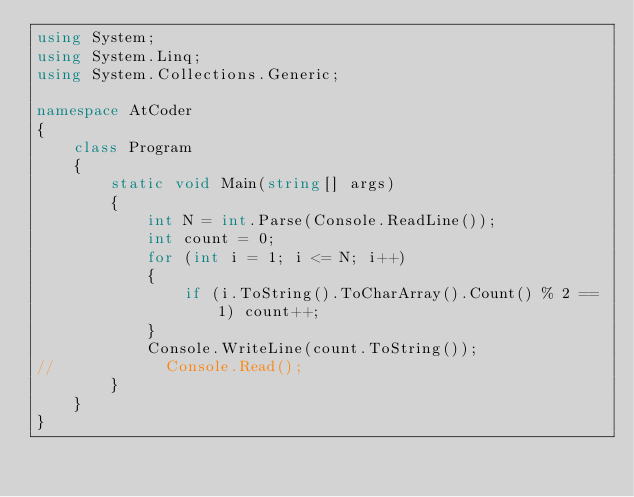<code> <loc_0><loc_0><loc_500><loc_500><_C#_>using System;
using System.Linq;
using System.Collections.Generic;

namespace AtCoder
{
    class Program
    {
        static void Main(string[] args)
        {
            int N = int.Parse(Console.ReadLine());
            int count = 0;
            for (int i = 1; i <= N; i++)
            {
                if (i.ToString().ToCharArray().Count() % 2 == 1) count++;
            }
            Console.WriteLine(count.ToString());
//            Console.Read();
        }
    }
}</code> 